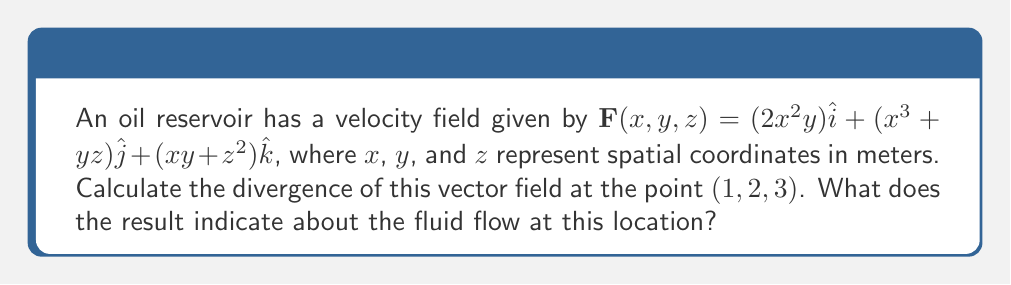Can you answer this question? To solve this problem, we'll follow these steps:

1) The divergence of a vector field $\mathbf{F}(x,y,z) = P\hat{i} + Q\hat{j} + R\hat{k}$ is given by:

   $$\nabla \cdot \mathbf{F} = \frac{\partial P}{\partial x} + \frac{\partial Q}{\partial y} + \frac{\partial R}{\partial z}$$

2) In our case:
   $P = 2x^2y$
   $Q = x^3+yz$
   $R = xy+z^2$

3) Let's calculate each partial derivative:

   $$\frac{\partial P}{\partial x} = \frac{\partial}{\partial x}(2x^2y) = 4xy$$
   
   $$\frac{\partial Q}{\partial y} = \frac{\partial}{\partial y}(x^3+yz) = z$$
   
   $$\frac{\partial R}{\partial z} = \frac{\partial}{\partial z}(xy+z^2) = 2z$$

4) Now, we can sum these partial derivatives:

   $$\nabla \cdot \mathbf{F} = 4xy + z + 2z = 4xy + 3z$$

5) Evaluate this at the point $(1,2,3)$:

   $$\nabla \cdot \mathbf{F}(1,2,3) = 4(1)(2) + 3(3) = 8 + 9 = 17 \text{ m}^{-2}$$

6) Interpretation: The positive divergence indicates that this point is a source in the fluid flow, meaning fluid is flowing outward from this location. The magnitude of 17 m^-2 suggests a significant outward flow rate.
Answer: $17 \text{ m}^{-2}$, indicating a source in the fluid flow 